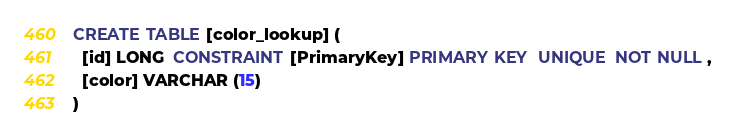Convert code to text. <code><loc_0><loc_0><loc_500><loc_500><_SQL_>CREATE TABLE [color_lookup] (
  [id] LONG  CONSTRAINT [PrimaryKey] PRIMARY KEY  UNIQUE  NOT NULL ,
  [color] VARCHAR (15)
)
</code> 